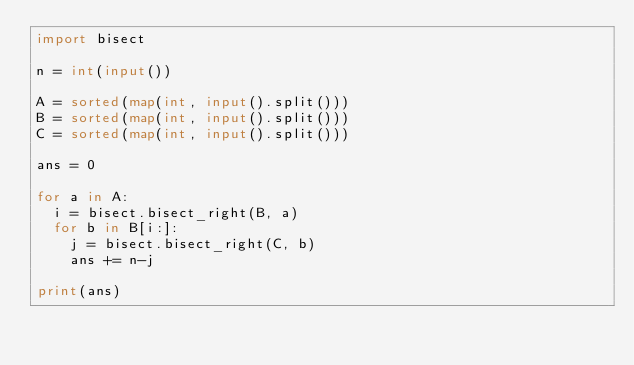Convert code to text. <code><loc_0><loc_0><loc_500><loc_500><_Python_>import bisect

n = int(input())

A = sorted(map(int, input().split()))
B = sorted(map(int, input().split()))
C = sorted(map(int, input().split()))

ans = 0

for a in A:
  i = bisect.bisect_right(B, a)
  for b in B[i:]:
    j = bisect.bisect_right(C, b)
    ans += n-j
    
print(ans)</code> 